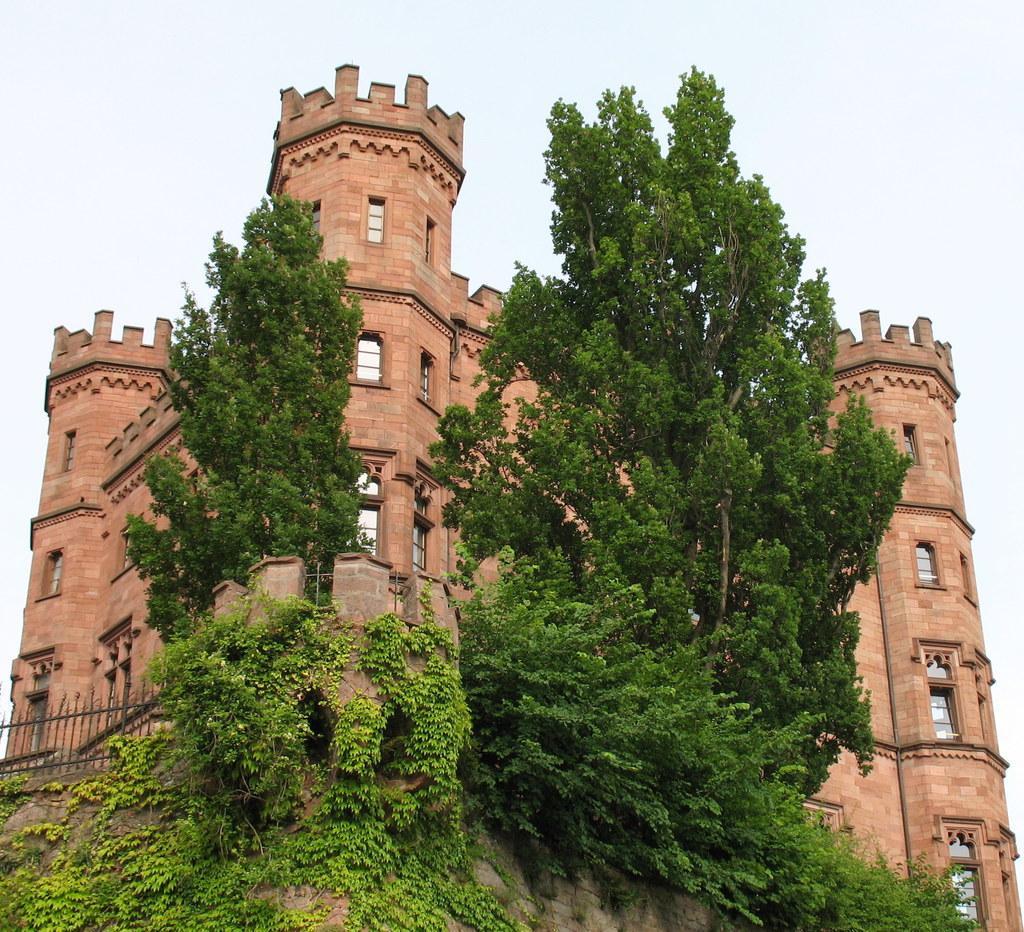Please provide a concise description of this image. In this image we can see a building and it is having many windows. There are two trees and many plants in the image. There is a fencing in the image. There is a sky in the image. 